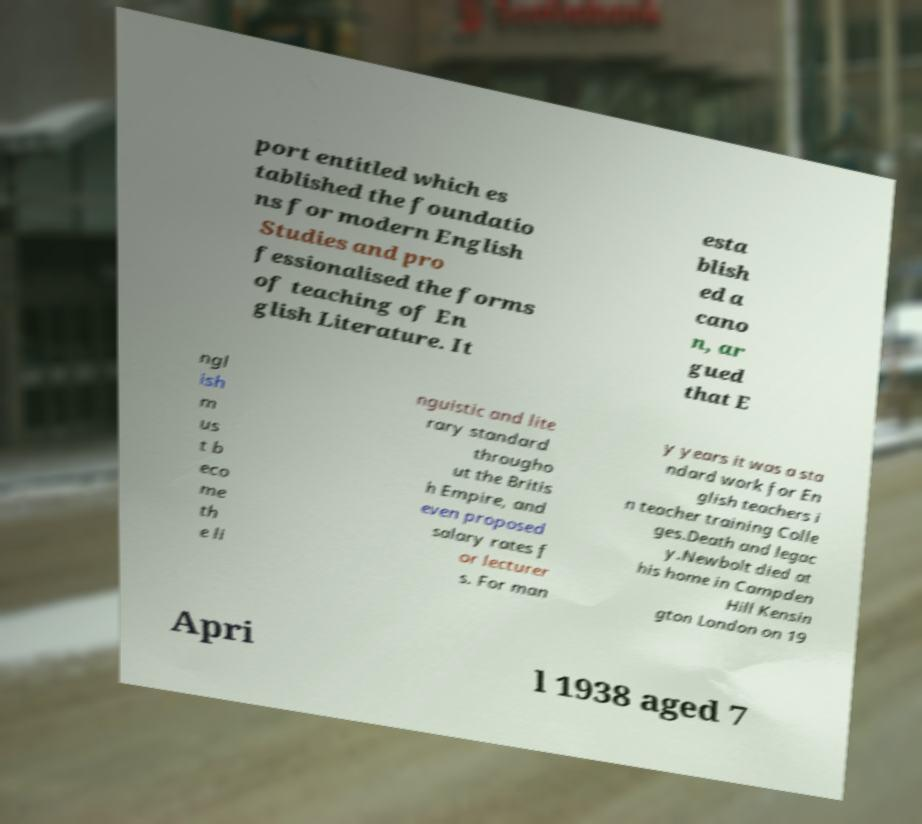Could you extract and type out the text from this image? port entitled which es tablished the foundatio ns for modern English Studies and pro fessionalised the forms of teaching of En glish Literature. It esta blish ed a cano n, ar gued that E ngl ish m us t b eco me th e li nguistic and lite rary standard througho ut the Britis h Empire, and even proposed salary rates f or lecturer s. For man y years it was a sta ndard work for En glish teachers i n teacher training Colle ges.Death and legac y.Newbolt died at his home in Campden Hill Kensin gton London on 19 Apri l 1938 aged 7 